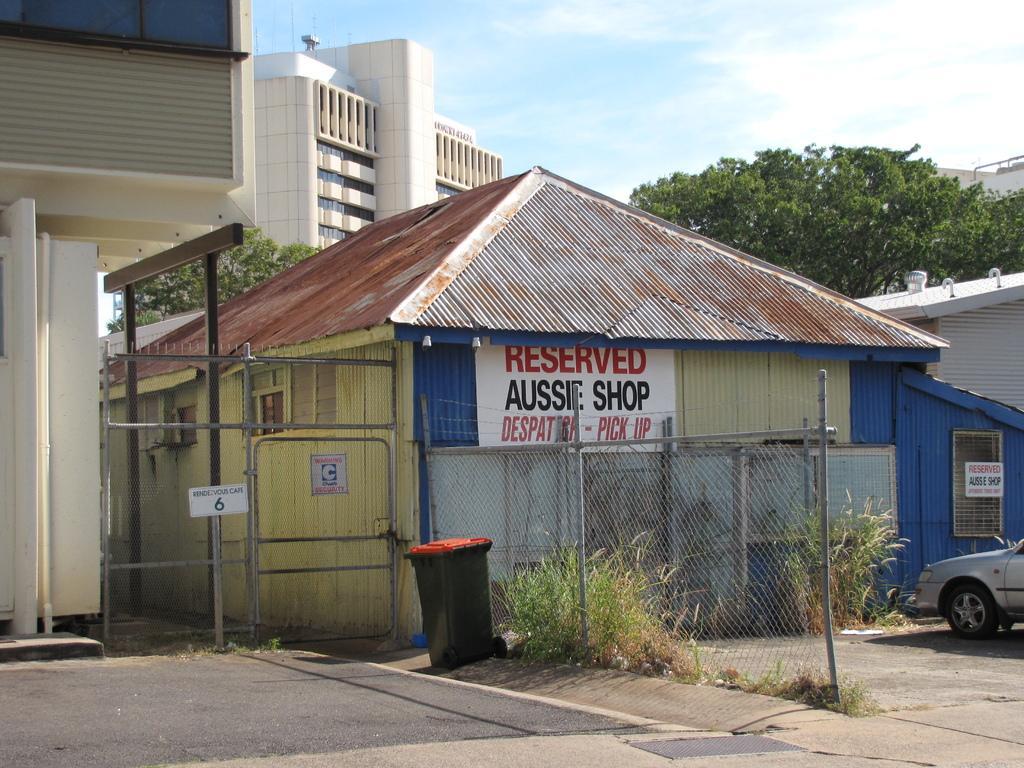How would you summarize this image in a sentence or two? In the middle of the image we can see a dustbin. Behind the dustbin we can see fencing. Behind the fencing we can see some buildings, trees, vehicles and plants. At the top of the image we can see some clouds in the sky. 